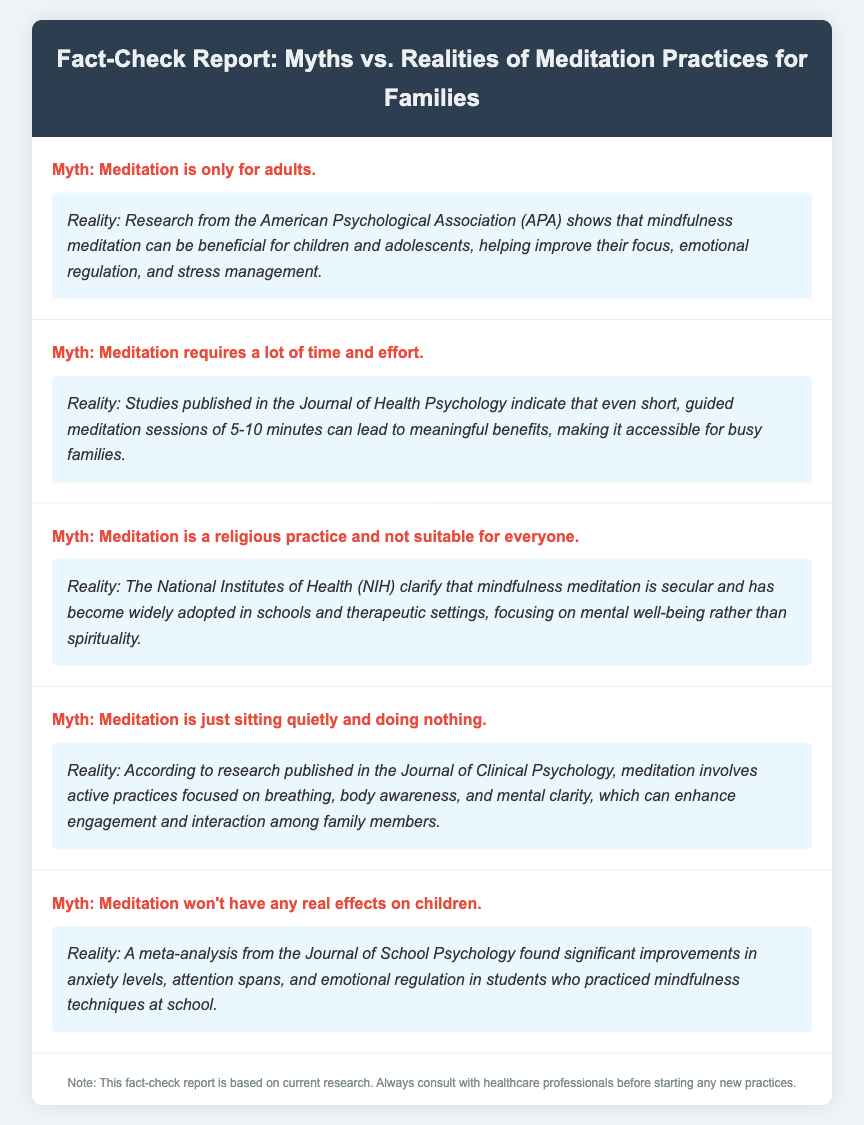What is one benefit of meditation for children? The document states that mindfulness meditation can help improve children's focus, emotional regulation, and stress management.
Answer: focus, emotional regulation, stress management How long do the studies suggest meditation sessions can be? The Journal of Health Psychology indicates that even short, guided meditation sessions of 5-10 minutes can lead to meaningful benefits.
Answer: 5-10 minutes Which organization clarifies that mindfulness meditation is secular? The National Institutes of Health (NIH) clarifies that mindfulness meditation is secular.
Answer: National Institutes of Health What kind of practices does meditation involve according to the document? The document indicates that meditation involves active practices focused on breathing, body awareness, and mental clarity.
Answer: breathing, body awareness, mental clarity What improvement was found in students who practiced mindfulness techniques? A meta-analysis found significant improvements in anxiety levels, attention spans, and emotional regulation in students.
Answer: anxiety levels, attention spans, emotional regulation 